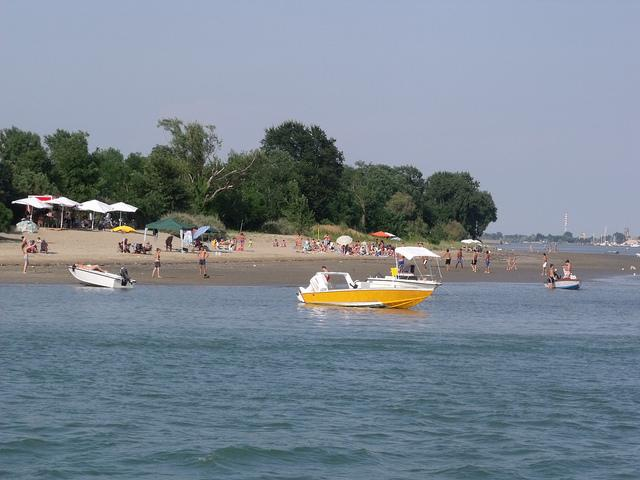What energy moves these boats? gas 